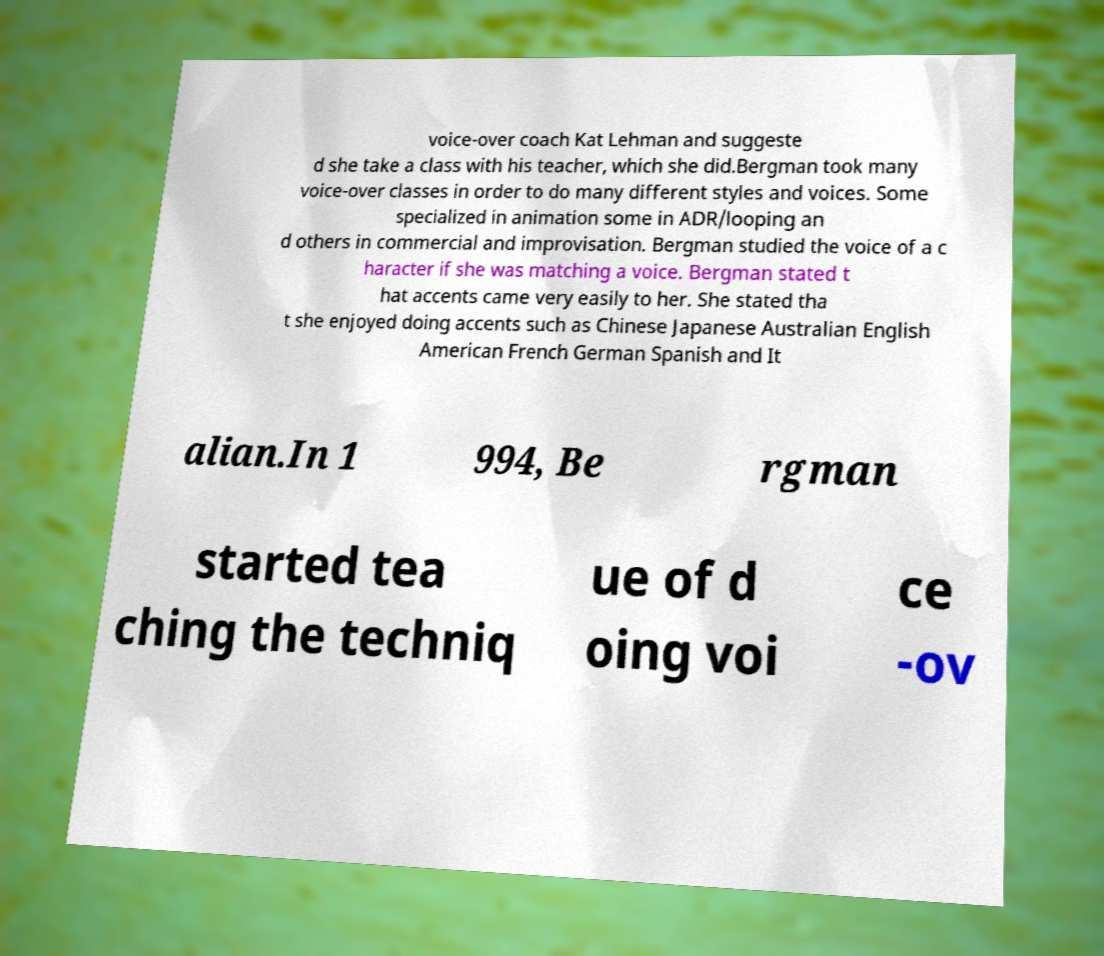There's text embedded in this image that I need extracted. Can you transcribe it verbatim? voice-over coach Kat Lehman and suggeste d she take a class with his teacher, which she did.Bergman took many voice-over classes in order to do many different styles and voices. Some specialized in animation some in ADR/looping an d others in commercial and improvisation. Bergman studied the voice of a c haracter if she was matching a voice. Bergman stated t hat accents came very easily to her. She stated tha t she enjoyed doing accents such as Chinese Japanese Australian English American French German Spanish and It alian.In 1 994, Be rgman started tea ching the techniq ue of d oing voi ce -ov 